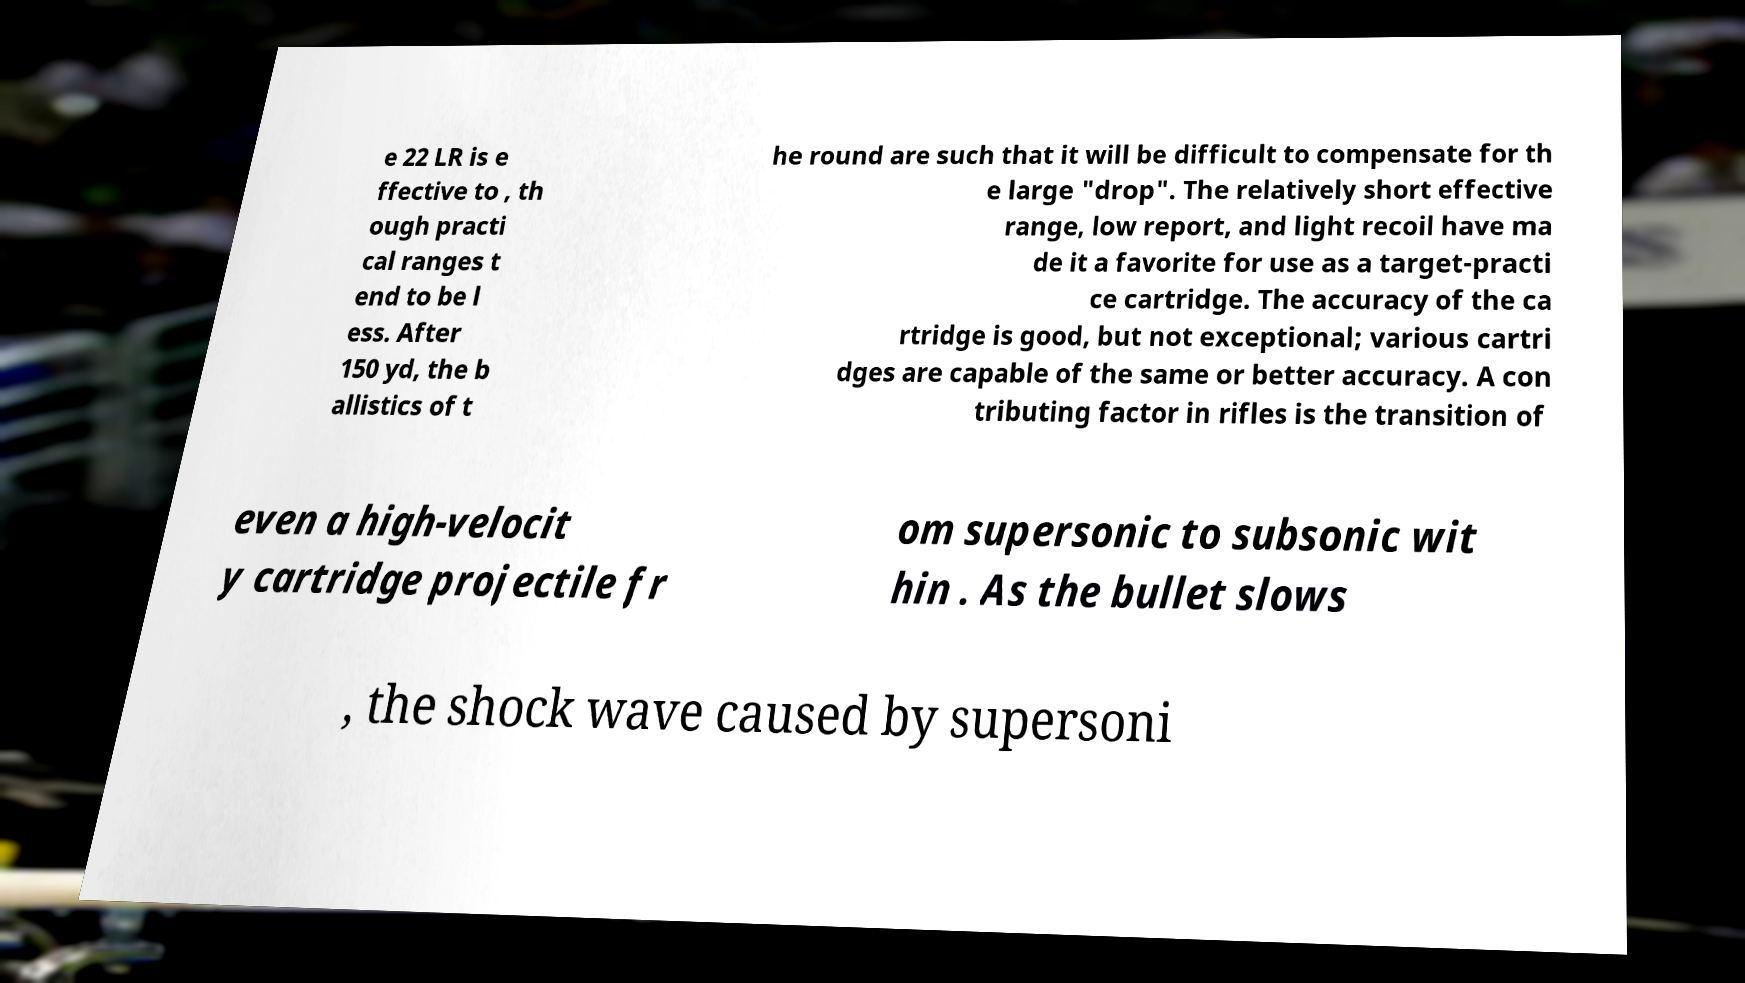For documentation purposes, I need the text within this image transcribed. Could you provide that? e 22 LR is e ffective to , th ough practi cal ranges t end to be l ess. After 150 yd, the b allistics of t he round are such that it will be difficult to compensate for th e large "drop". The relatively short effective range, low report, and light recoil have ma de it a favorite for use as a target-practi ce cartridge. The accuracy of the ca rtridge is good, but not exceptional; various cartri dges are capable of the same or better accuracy. A con tributing factor in rifles is the transition of even a high-velocit y cartridge projectile fr om supersonic to subsonic wit hin . As the bullet slows , the shock wave caused by supersoni 